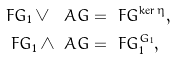<formula> <loc_0><loc_0><loc_500><loc_500>\ F G _ { 1 } \vee \ A G & = \ F G ^ { \ker \eta } , \\ \ F G _ { 1 } \wedge \ A G & = \ F G _ { 1 } ^ { G _ { 1 } } ,</formula> 